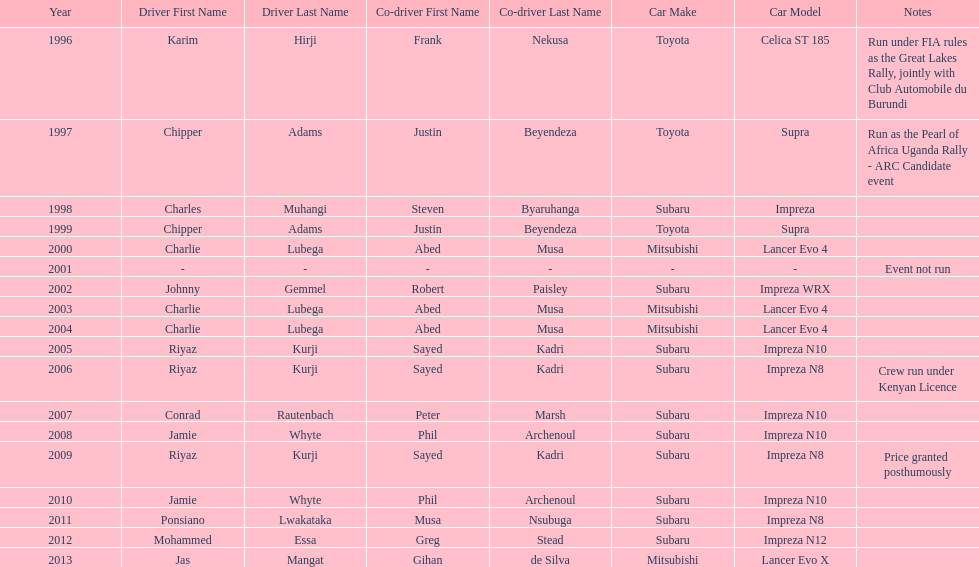How many times was charlie lubega a driver? 3. 